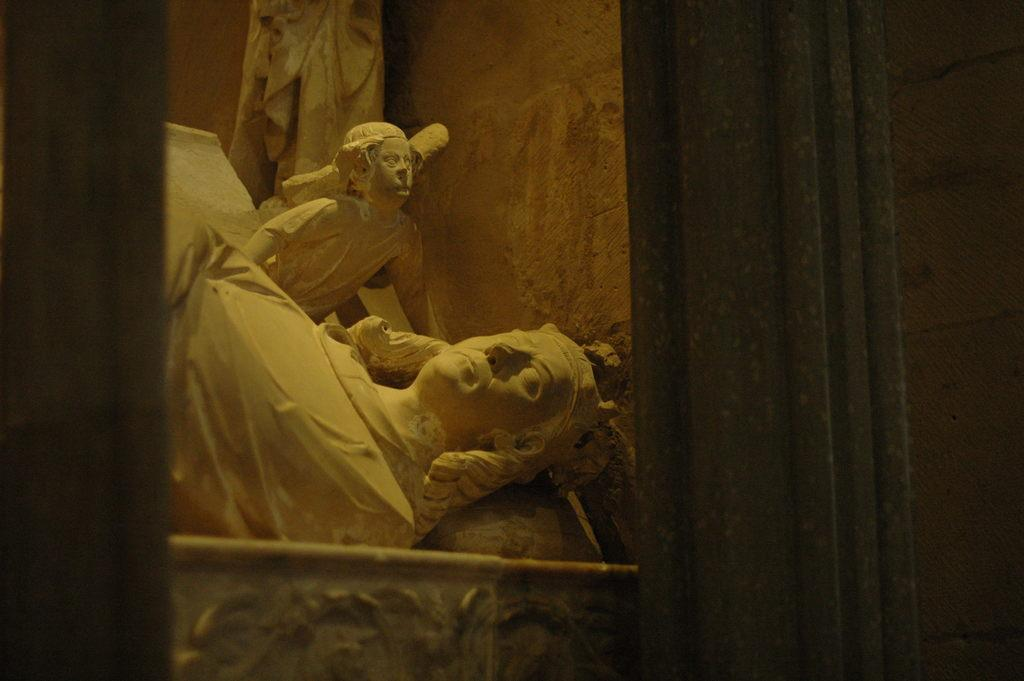What can be found in the center of the image? There are statues in the middle of the image. What is located on the right side of the image? There is a curtain on the right side of the image. What can be seen in the background of the image? There is a wall visible in the background of the image. How many boats are present in the image? There are no boats present in the image; it features statues, a curtain, and a wall. What type of ornament is hanging from the curtain in the image? There is no ornament hanging from the curtain in the image; only the curtain itself is visible. 